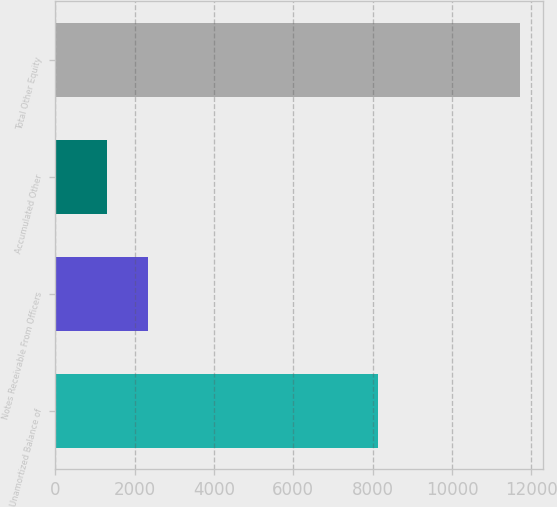<chart> <loc_0><loc_0><loc_500><loc_500><bar_chart><fcel>Unamortized Balance of<fcel>Notes Receivable From Officers<fcel>Accumulated Other<fcel>Total Other Equity<nl><fcel>8142<fcel>2344.1<fcel>1304<fcel>11705<nl></chart> 